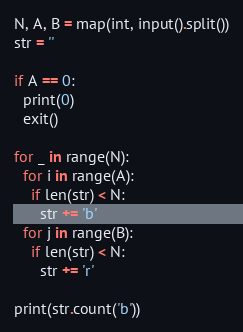<code> <loc_0><loc_0><loc_500><loc_500><_Python_>N, A, B = map(int, input().split())
str = ''

if A == 0:
  print(0)
  exit()
  
for _ in range(N):
  for i in range(A):
    if len(str) < N:
      str += 'b'
  for j in range(B):
    if len(str) < N:
      str += 'r'

print(str.count('b'))</code> 